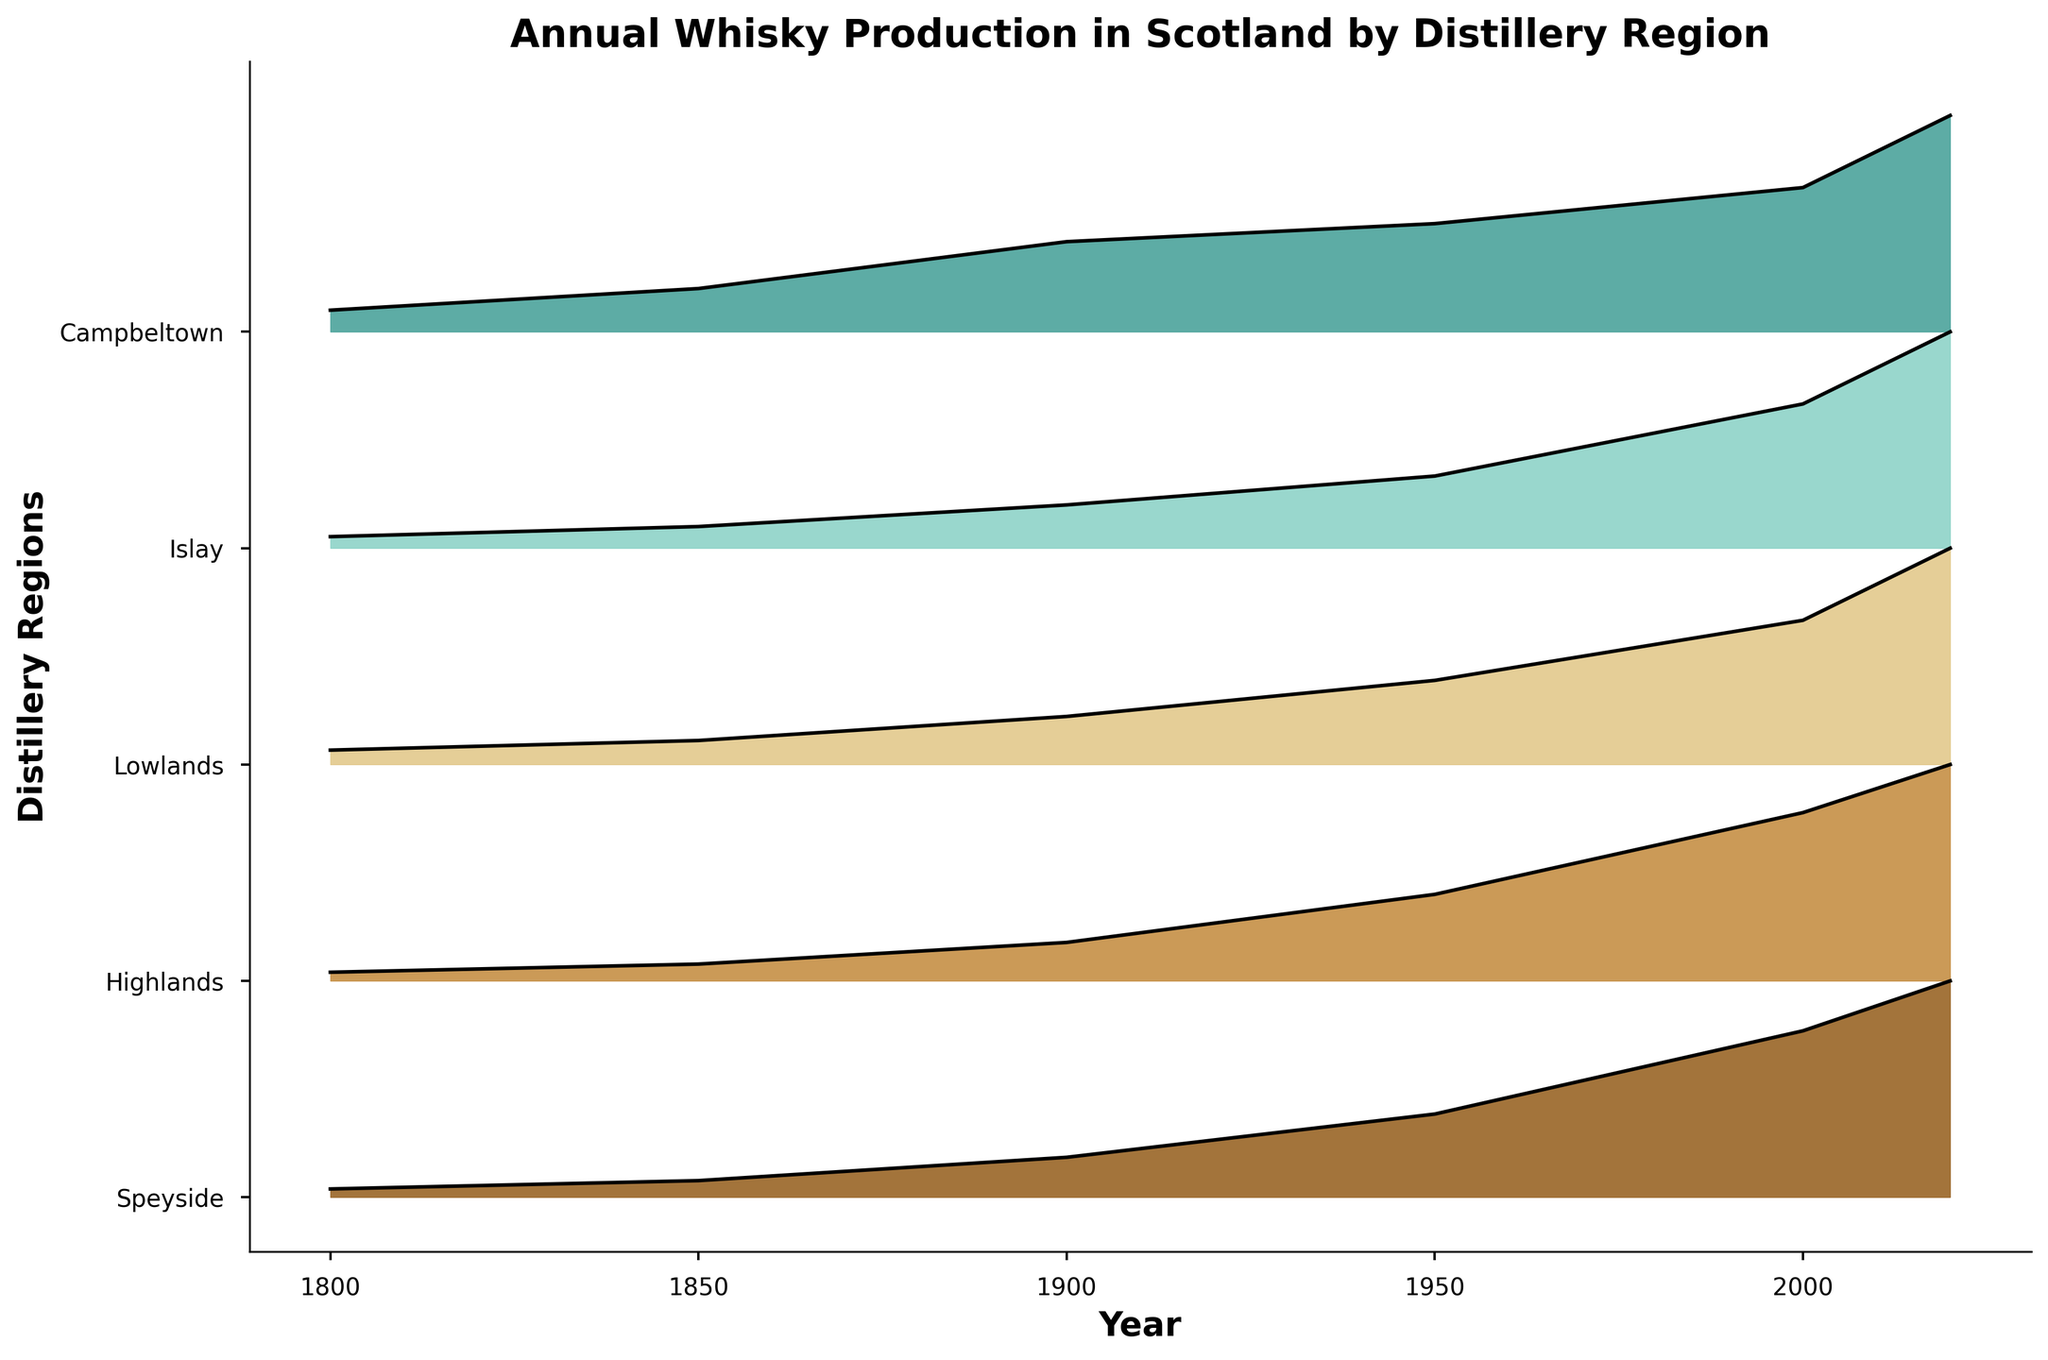What is the title of the figure? The title is visibly written at the top of the figure and usually summarizes the information presented.
Answer: Annual Whisky Production in Scotland by Distillery Region How many distillery regions are shown in the figure? The number of distinct areas labeled on the y-axis represents the different distillery regions.
Answer: Five Which distillery region showed the highest production in 2020? By observing the peaks at the rightmost side of the ridgeline plot under the year 2020, we find which region reaches the highest value.
Answer: Speyside Comparing productions in 1800 and 2020, which region has seen the most significant increase? By comparing the heights of the filled areas for each region between the years 1800 and 2020, we can determine the region with the largest change in production.
Answer: Speyside What is the approximate production level (relative to its respective maximum) for the Highlands region in 1950? Locate 1950 on the x-axis and observe the height of the filled area for the Highlands region at that year relative to its maximum value.
Answer: 18,000 Between 1900 and 2000, which region's production showed the least relative increase? By comparing the relative increase in the heights of the filled areas between the years 1900 and 2000 for all regions, we can identify the region with the smallest change.
Answer: Campbeltown Which distillery region consistently had the lowest production throughout the years represented? By observing the lowest filled areas across the plot, identify the region that stayed at the bottom consistently over the years.
Answer: Campbeltown During which time period did Islay see the most substantial relative growth in production? By comparing the heights of Islay's filled areas across different year intervals, identify where the most notable growth occurred.
Answer: 1950 to 2000 Has any region shown a decrease in production over any period shown? If yes, which and during what years? By looking for filled areas that decrease in height as you move from left to right across the x-axis, we can detect any decreases in production.
Answer: No, all regions show increasing trends overall 